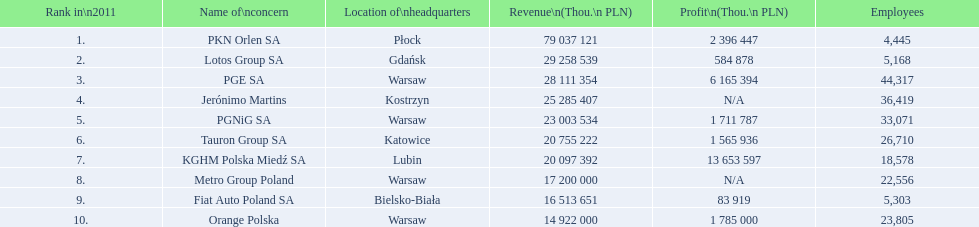Which firm's head office is located in warsaw? PGE SA, PGNiG SA, Metro Group Poland. Which of these outlined showed a profit? PGE SA, PGNiG SA. Of these, how many personnel are in the business with the least profit? 33,071. 